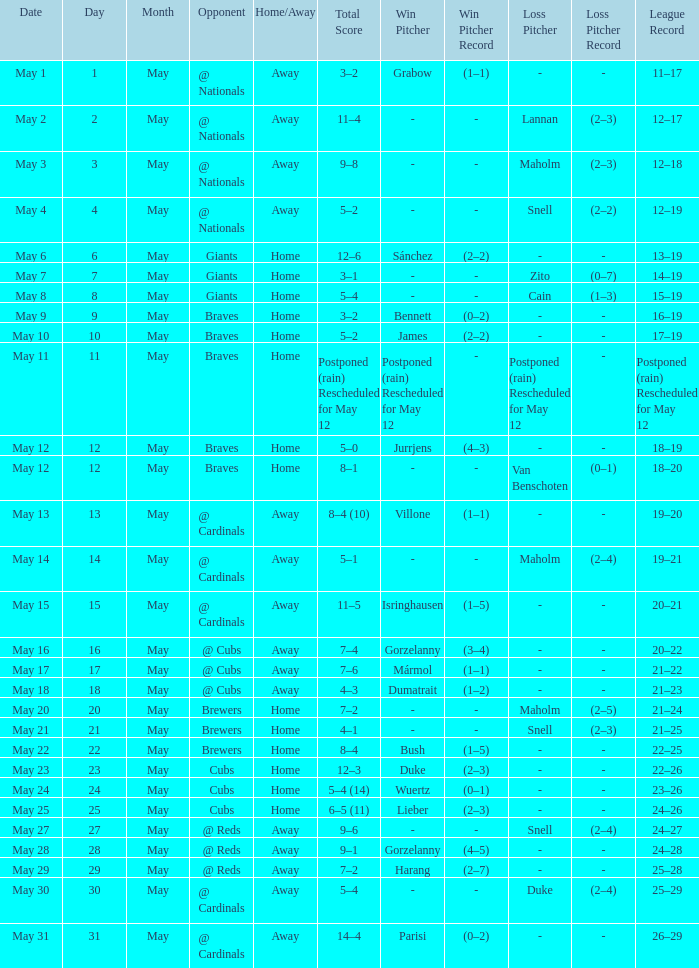What was the score of the game with a loss of Maholm (2–4)? 5–1. 